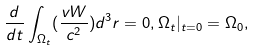<formula> <loc_0><loc_0><loc_500><loc_500>\frac { d } { d t } \int _ { \Omega _ { t } } ( \frac { v W } { c ^ { 2 } } ) d ^ { 3 } r = 0 , \Omega _ { t } | _ { t = 0 } = \Omega _ { 0 } ,</formula> 